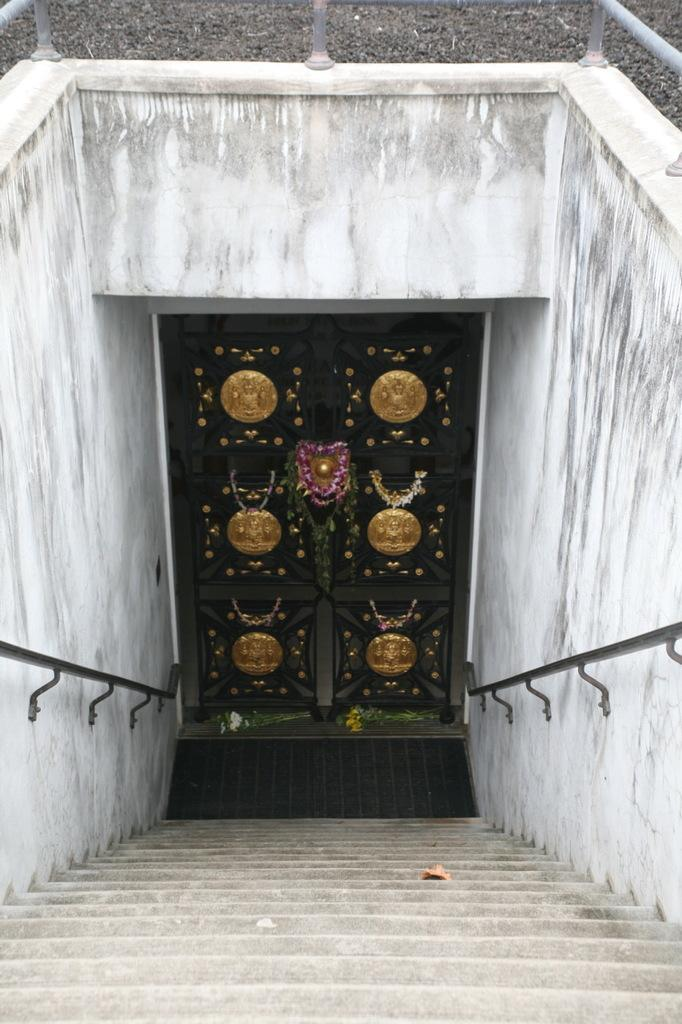What is one of the main features of the image? There is a door in the image. What is placed in front of the door? There is a mat in the image. What type of structure can be seen in the background of the image? There is a wall in the image. What type of tail can be seen on the chair in the image? There is no chair or tail present in the image. What hobbies are the people in the image engaged in? There are no people present in the image, so their hobbies cannot be determined. 